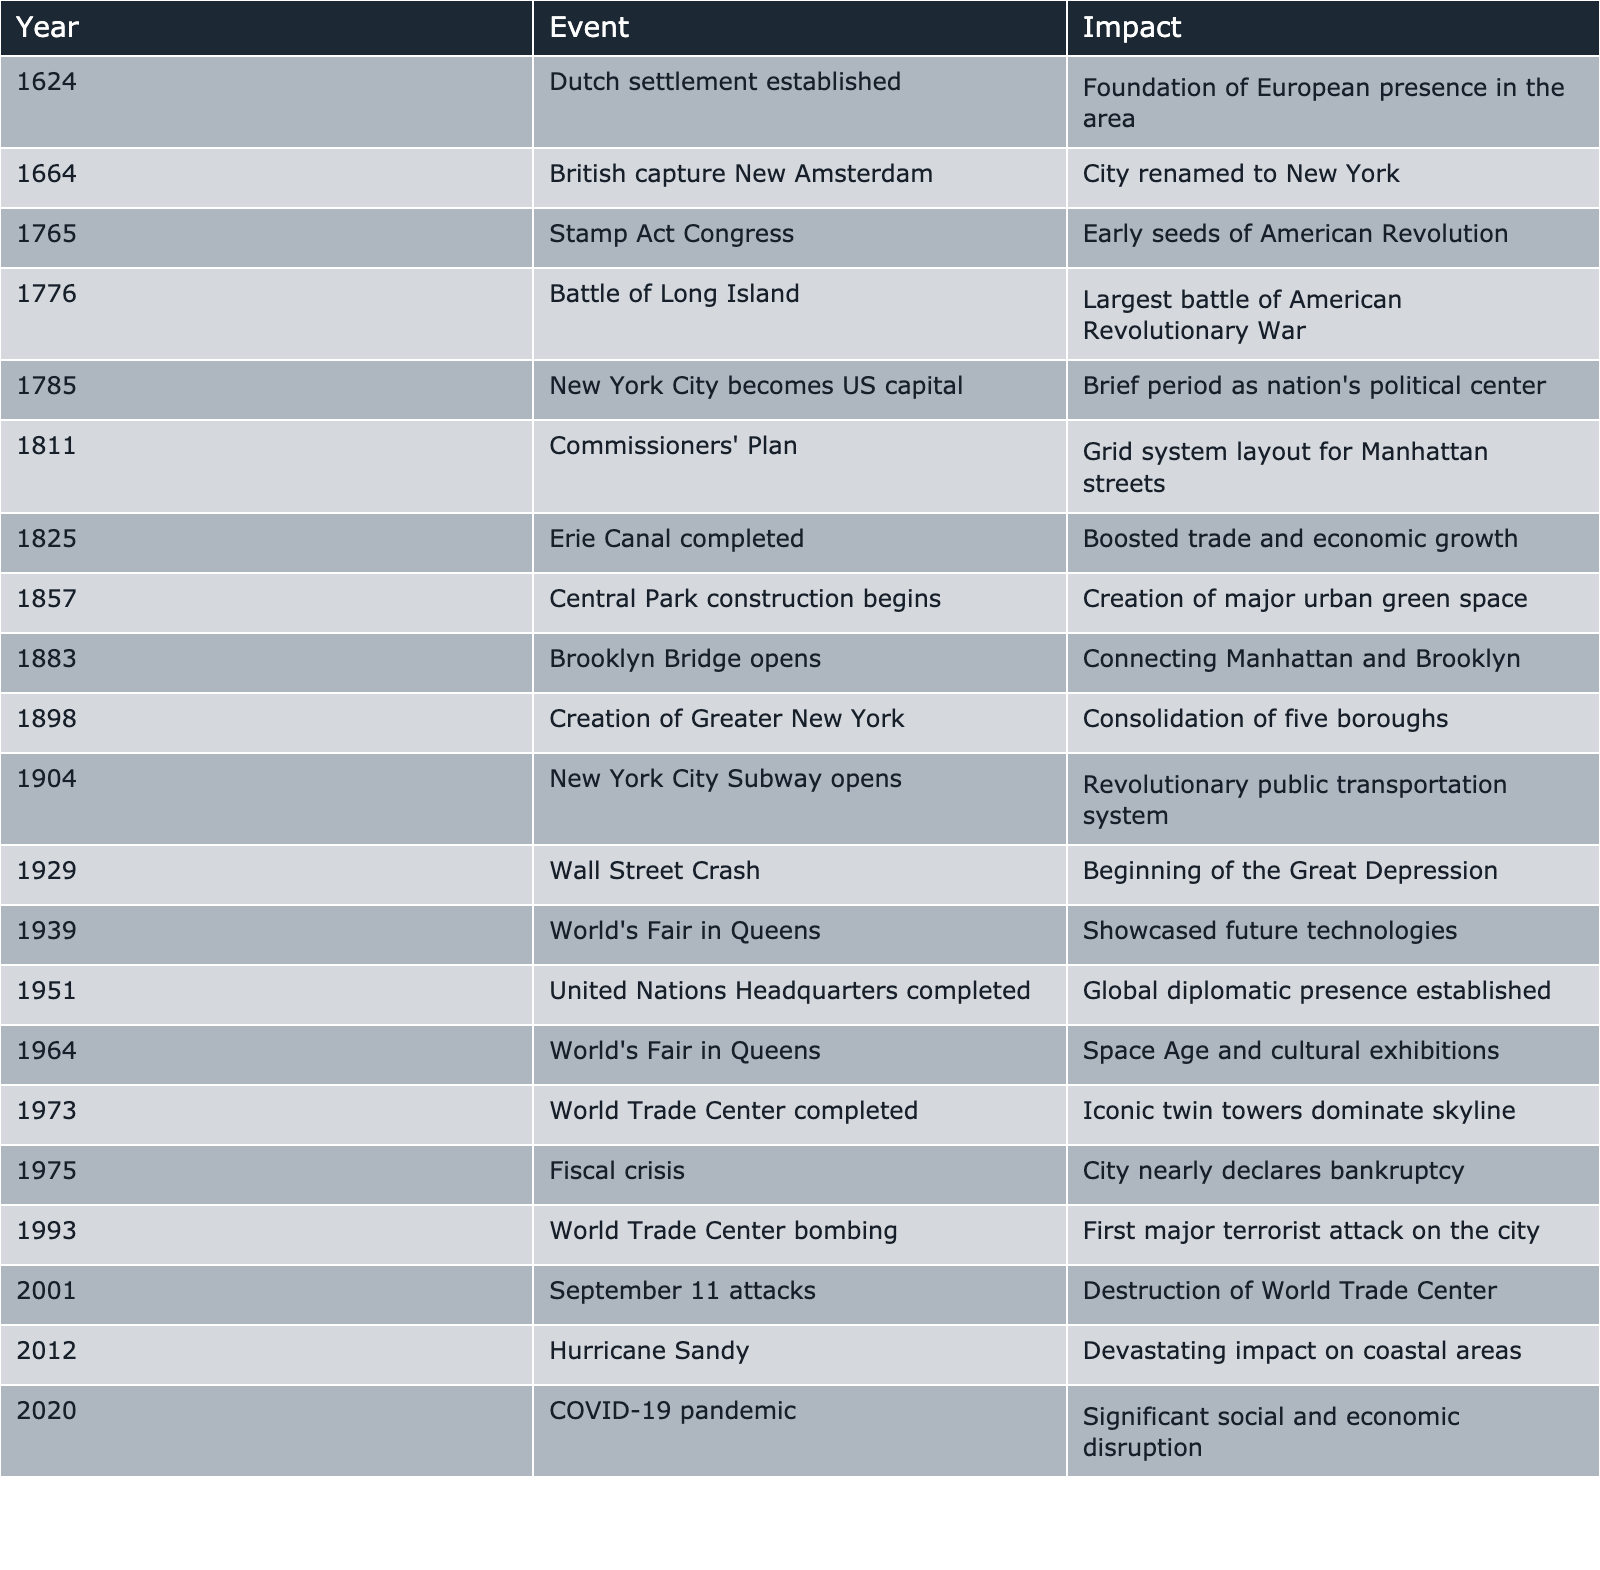What year did New York City become the US capital? According to the table, New York City became the US capital in the year 1785.
Answer: 1785 Which event marked the beginning of the Great Depression? The Wall Street Crash in 1929 is listed in the table as the event that marked the beginning of the Great Depression.
Answer: Wall Street Crash in 1929 What was the impact of the Erie Canal completion? The Erie Canal’s completion in 1825 significantly boosted trade and economic growth, as indicated in the table.
Answer: Boosted trade and economic growth How many major events occurred in the 20th century according to the table? There are eight events listed in the table that occurred in the 20th century (1904 to 2001), indicating significant historical milestones.
Answer: Eight Did the construction of Central Park begin before the opening of the New York City Subway? Yes, Central Park construction began in 1857, while the New York City Subway opened in 1904, making it true that Central Park's construction started earlier.
Answer: Yes What is the difference in years between the establishment of the Dutch settlement and the completion of the United Nations Headquarters? The Dutch settlement was established in 1624, and the United Nations Headquarters was completed in 1951. The difference is 1951 - 1624 = 327 years.
Answer: 327 years Which major event happened closest to the year 2000? The September 11 attacks occurred in 2001, which is the closest major event to the year 2000 according to the table.
Answer: September 11 attacks in 2001 How many events listed involved the World’s Fair? The table shows that there were two World’s Fair events that took place in Queens, one in 1939 and another in 1964.
Answer: Two events Was the Battle of Long Island the largest battle of the American Revolutionary War? Yes, the table states that the Battle of Long Island, which occurred in 1776, was the largest battle of the American Revolutionary War.
Answer: Yes What is the average year at which the major historical events occurred from 1624 to 2020? To find the average, calculate the sum of years (1624 + 1664 + 1765 + 1776 + 1785 + 1811 + 1825 + 1857 + 1883 + 1898 + 1904 + 1929 + 1939 + 1951 + 1964 + 1973 + 1975 + 1993 + 2001 + 2012 + 2020 = 36670) and divide by the number of events (20), resulting in an average year of 1833.5.
Answer: 1833.5 